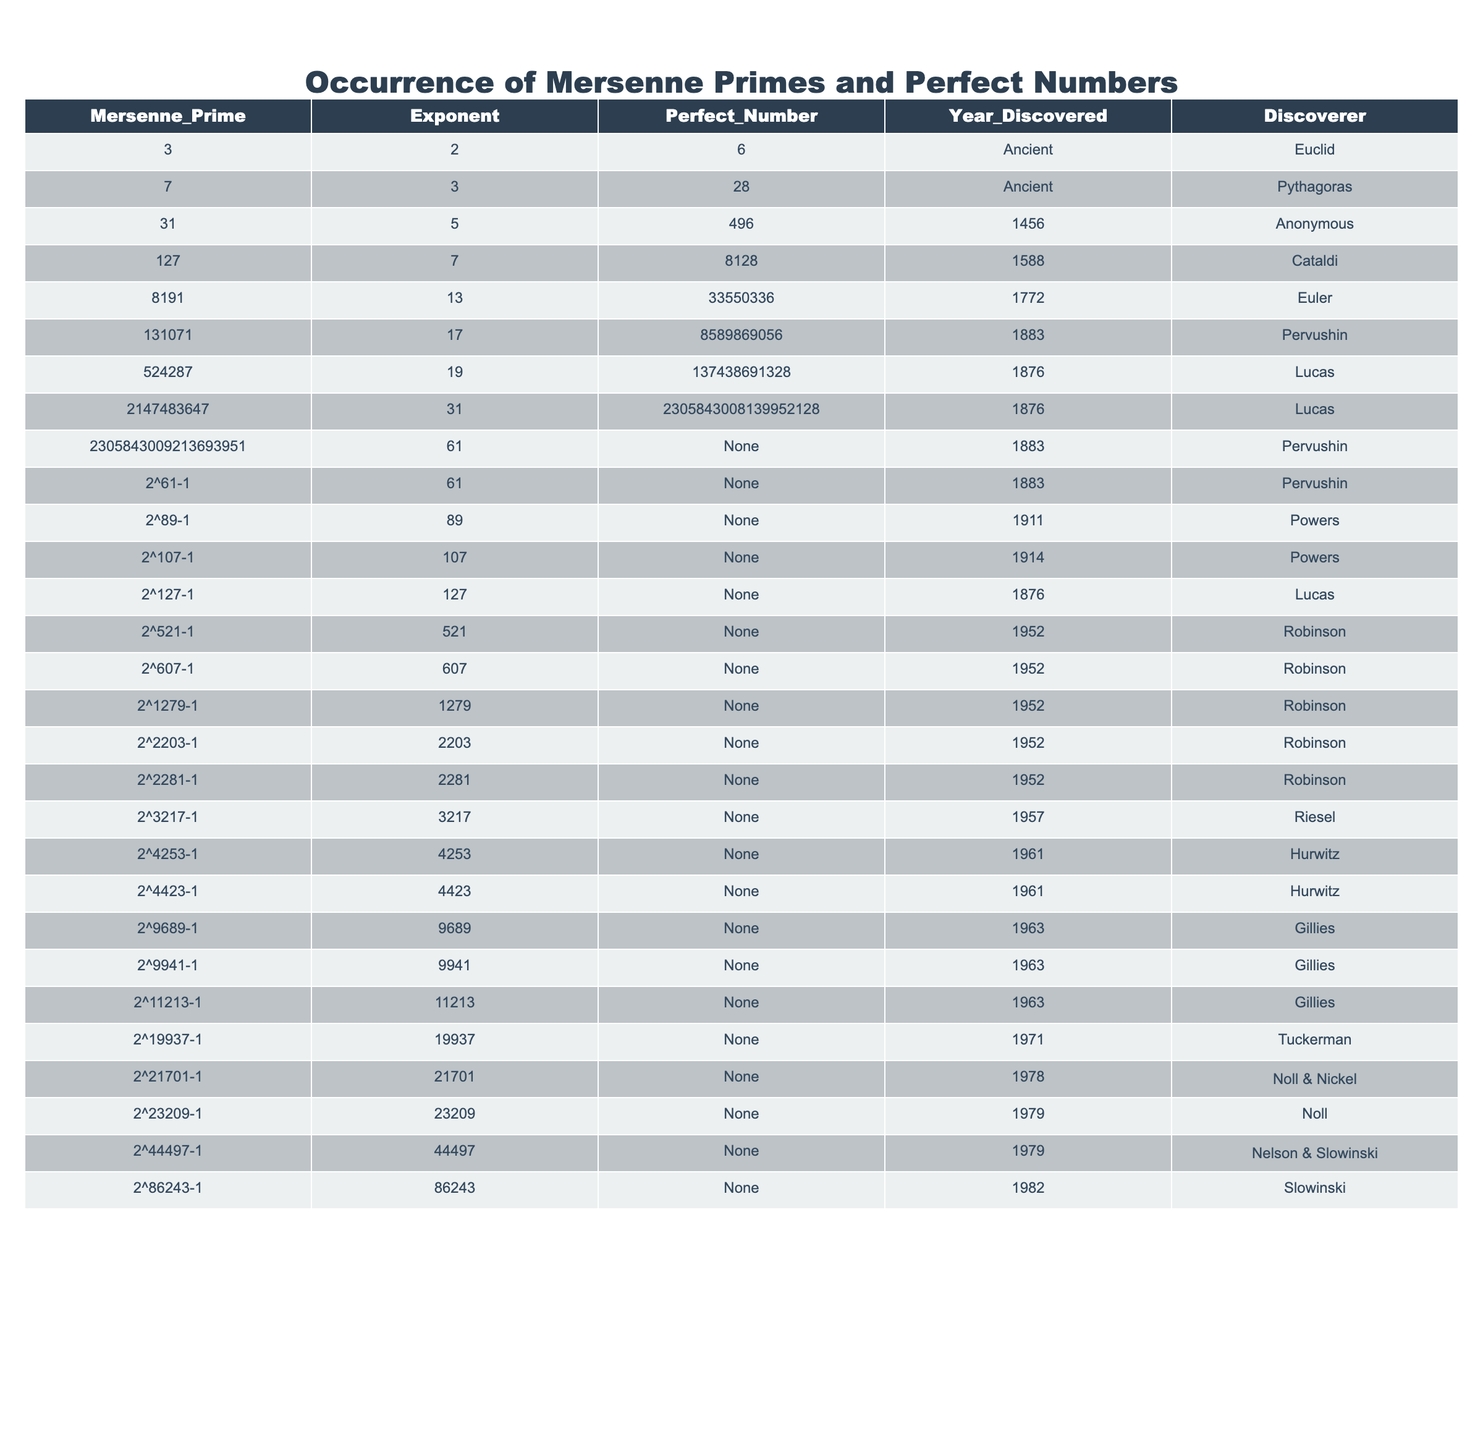What is the highest Mersenne prime listed in the table? By examining the 'Mersenne_Prime' column, the highest value is identified, which is 2^86243-1.
Answer: 2^86243-1 Who discovered the perfect number 6? Referring to the 'Perfect_Number' and 'Discoverer' columns, it shows that the perfect number 6 was discovered by Euclid.
Answer: Euclid How many perfect numbers are linked to Mersenne primes discovered in ancient times? From the table, two perfect numbers (6 and 28) are connected to Mersenne primes discovered in ancient times, which were the first two entries.
Answer: 2 Is there a known perfect number associated with the Mersenne prime of 2305843009213693951? The 'Perfect_Number' column indicates 'None' for this Mersenne prime, confirming that there is no perfect number associated with it.
Answer: No What year was the Mersenne prime with exponent 61 discovered? By checking the 'Exponent' and 'Year_Discovered' columns, the year for exponent 61 is listed as 1883.
Answer: 1883 Which discoverer found the most Mersenne primes? Analyzing the 'Discoverer' column, Robinson is listed multiple times, specifically for Mersenne primes with exponents 521, 607, 1279, 2203, 2281, indicating he discovered the most.
Answer: Robinson What is the relationship between the Mersenne prime 2147483647 and its perfect number? Looking at the 'Perfect_Number' column, it shows that the perfect number corresponding to the Mersenne prime 2147483647 is 2305843008139952128.
Answer: 2305843008139952128 Calculate the number of Mersenne primes discovered by Lucas. Count from the 'Discoverer' column, Lucas is mentioned for two Mersenne primes (exponents 19 and 127).
Answer: 2 Identify the earliest Mersenne prime listed in the table. The first row of the table represents the earliest Mersenne prime, which is 3 with an exponent of 2.
Answer: 3 What percentage of the perfect numbers listed are attributed to Ancient discoverers? Of the six perfect numbers, two (6 and 28) were discovered in ancient times. The percentage is (2/6) * 100 = 33.33%.
Answer: 33.33% 